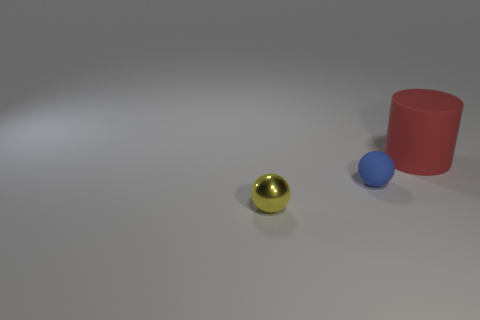Are there any other things that are the same size as the red rubber object?
Offer a very short reply. No. How big is the ball that is in front of the rubber object that is in front of the big rubber cylinder?
Keep it short and to the point. Small. Is the number of spheres right of the big red rubber cylinder the same as the number of red rubber objects that are left of the yellow shiny object?
Offer a very short reply. Yes. There is a rubber object to the left of the large rubber object; is there a small blue matte object that is in front of it?
Make the answer very short. No. There is a big object that is the same material as the blue ball; what shape is it?
Ensure brevity in your answer.  Cylinder. Are there any other things that have the same color as the metallic object?
Your answer should be very brief. No. What is the material of the thing to the right of the rubber object left of the red rubber thing?
Ensure brevity in your answer.  Rubber. Are there any yellow things that have the same shape as the tiny blue matte object?
Give a very brief answer. Yes. What number of other things are the same shape as the small yellow thing?
Give a very brief answer. 1. There is a object that is both right of the small yellow sphere and on the left side of the large red object; what is its shape?
Make the answer very short. Sphere. 